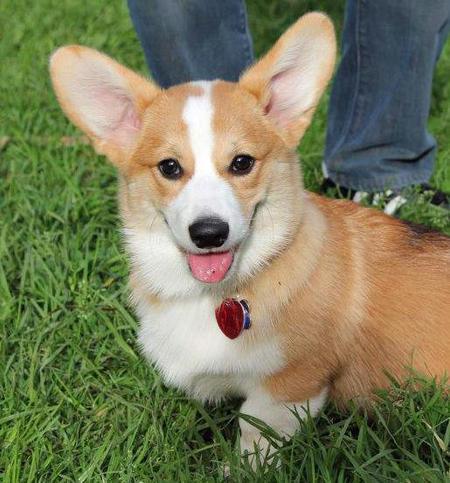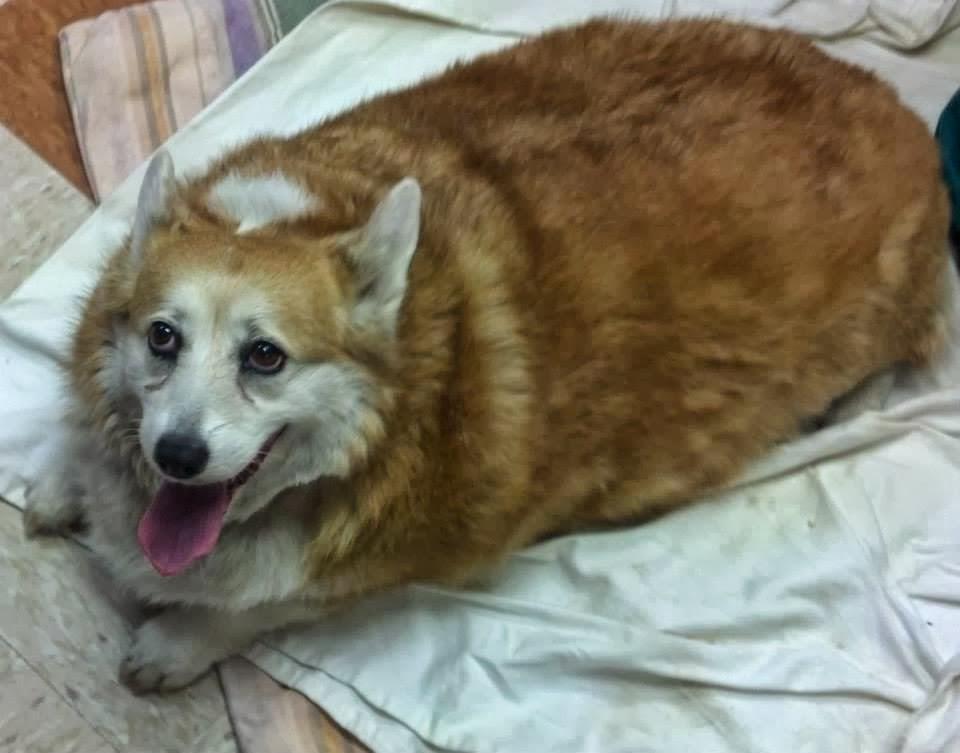The first image is the image on the left, the second image is the image on the right. For the images shown, is this caption "One image contains two dogs, sitting on a wooden slat deck or floor, while no image in the set contains green grass." true? Answer yes or no. No. The first image is the image on the left, the second image is the image on the right. Evaluate the accuracy of this statement regarding the images: "There is at least three dogs.". Is it true? Answer yes or no. No. 